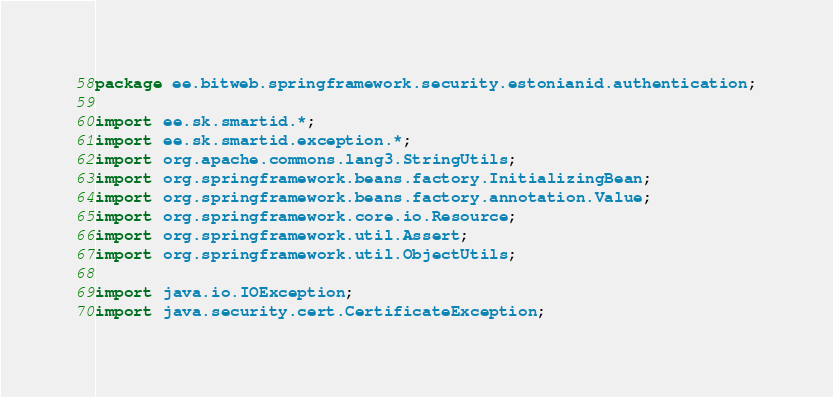Convert code to text. <code><loc_0><loc_0><loc_500><loc_500><_Java_>package ee.bitweb.springframework.security.estonianid.authentication;

import ee.sk.smartid.*;
import ee.sk.smartid.exception.*;
import org.apache.commons.lang3.StringUtils;
import org.springframework.beans.factory.InitializingBean;
import org.springframework.beans.factory.annotation.Value;
import org.springframework.core.io.Resource;
import org.springframework.util.Assert;
import org.springframework.util.ObjectUtils;

import java.io.IOException;
import java.security.cert.CertificateException;</code> 